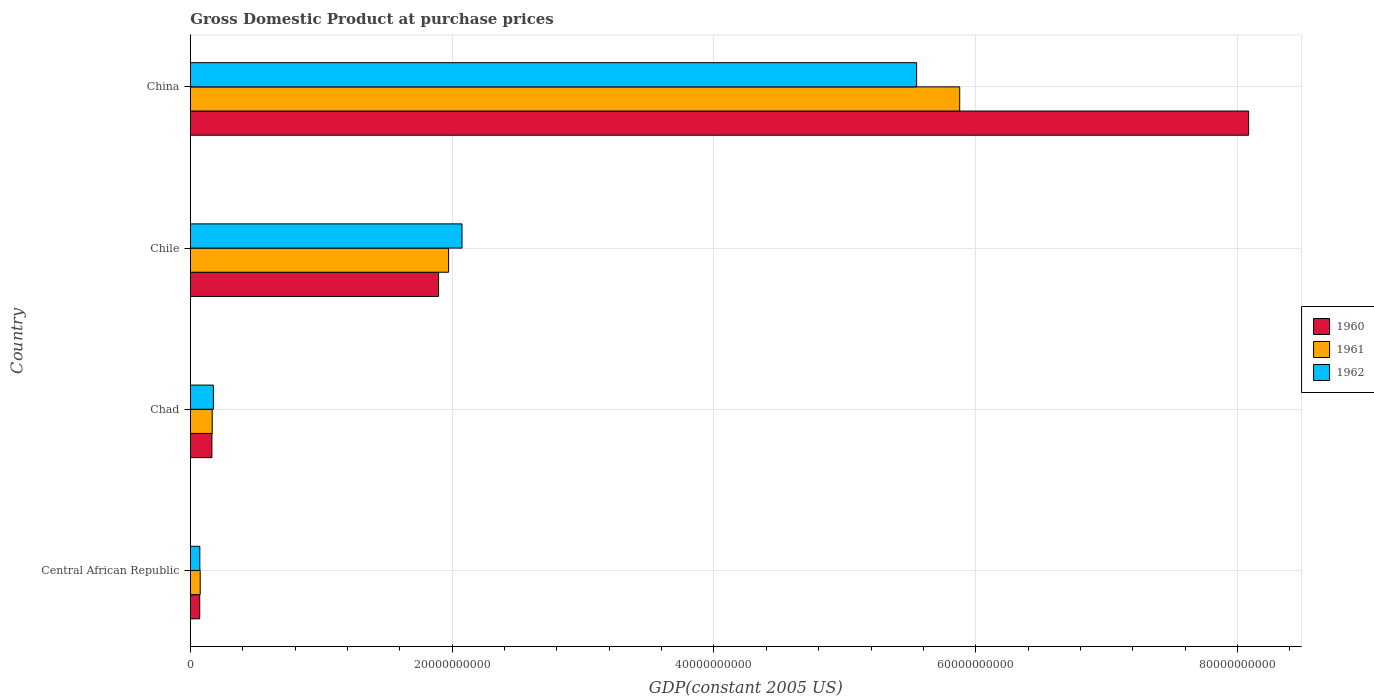How many different coloured bars are there?
Your answer should be compact. 3. How many bars are there on the 3rd tick from the top?
Your answer should be very brief. 3. How many bars are there on the 4th tick from the bottom?
Offer a terse response. 3. What is the label of the 3rd group of bars from the top?
Make the answer very short. Chad. In how many cases, is the number of bars for a given country not equal to the number of legend labels?
Keep it short and to the point. 0. What is the GDP at purchase prices in 1960 in Central African Republic?
Provide a short and direct response. 7.21e+08. Across all countries, what is the maximum GDP at purchase prices in 1961?
Your answer should be compact. 5.88e+1. Across all countries, what is the minimum GDP at purchase prices in 1960?
Provide a short and direct response. 7.21e+08. In which country was the GDP at purchase prices in 1962 minimum?
Your answer should be compact. Central African Republic. What is the total GDP at purchase prices in 1960 in the graph?
Your response must be concise. 1.02e+11. What is the difference between the GDP at purchase prices in 1961 in Chile and that in China?
Your answer should be compact. -3.90e+1. What is the difference between the GDP at purchase prices in 1962 in Central African Republic and the GDP at purchase prices in 1961 in Chad?
Give a very brief answer. -9.46e+08. What is the average GDP at purchase prices in 1960 per country?
Give a very brief answer. 2.55e+1. What is the difference between the GDP at purchase prices in 1962 and GDP at purchase prices in 1960 in Chile?
Offer a terse response. 1.79e+09. In how many countries, is the GDP at purchase prices in 1961 greater than 44000000000 US$?
Ensure brevity in your answer.  1. What is the ratio of the GDP at purchase prices in 1962 in Chad to that in Chile?
Provide a succinct answer. 0.09. Is the GDP at purchase prices in 1960 in Chile less than that in China?
Your answer should be very brief. Yes. Is the difference between the GDP at purchase prices in 1962 in Chad and China greater than the difference between the GDP at purchase prices in 1960 in Chad and China?
Ensure brevity in your answer.  Yes. What is the difference between the highest and the second highest GDP at purchase prices in 1961?
Keep it short and to the point. 3.90e+1. What is the difference between the highest and the lowest GDP at purchase prices in 1960?
Offer a very short reply. 8.01e+1. What does the 1st bar from the top in Central African Republic represents?
Provide a short and direct response. 1962. Is it the case that in every country, the sum of the GDP at purchase prices in 1960 and GDP at purchase prices in 1962 is greater than the GDP at purchase prices in 1961?
Offer a very short reply. Yes. How many countries are there in the graph?
Offer a terse response. 4. What is the difference between two consecutive major ticks on the X-axis?
Give a very brief answer. 2.00e+1. Are the values on the major ticks of X-axis written in scientific E-notation?
Offer a terse response. No. How many legend labels are there?
Keep it short and to the point. 3. What is the title of the graph?
Offer a terse response. Gross Domestic Product at purchase prices. Does "1979" appear as one of the legend labels in the graph?
Make the answer very short. No. What is the label or title of the X-axis?
Make the answer very short. GDP(constant 2005 US). What is the GDP(constant 2005 US) of 1960 in Central African Republic?
Your answer should be very brief. 7.21e+08. What is the GDP(constant 2005 US) in 1961 in Central African Republic?
Your answer should be compact. 7.57e+08. What is the GDP(constant 2005 US) of 1962 in Central African Republic?
Keep it short and to the point. 7.29e+08. What is the GDP(constant 2005 US) of 1960 in Chad?
Keep it short and to the point. 1.65e+09. What is the GDP(constant 2005 US) of 1961 in Chad?
Your answer should be very brief. 1.68e+09. What is the GDP(constant 2005 US) of 1962 in Chad?
Offer a very short reply. 1.77e+09. What is the GDP(constant 2005 US) in 1960 in Chile?
Provide a succinct answer. 1.90e+1. What is the GDP(constant 2005 US) of 1961 in Chile?
Offer a terse response. 1.97e+1. What is the GDP(constant 2005 US) in 1962 in Chile?
Your response must be concise. 2.08e+1. What is the GDP(constant 2005 US) of 1960 in China?
Give a very brief answer. 8.08e+1. What is the GDP(constant 2005 US) of 1961 in China?
Your response must be concise. 5.88e+1. What is the GDP(constant 2005 US) of 1962 in China?
Your response must be concise. 5.55e+1. Across all countries, what is the maximum GDP(constant 2005 US) of 1960?
Offer a very short reply. 8.08e+1. Across all countries, what is the maximum GDP(constant 2005 US) in 1961?
Ensure brevity in your answer.  5.88e+1. Across all countries, what is the maximum GDP(constant 2005 US) in 1962?
Provide a short and direct response. 5.55e+1. Across all countries, what is the minimum GDP(constant 2005 US) in 1960?
Provide a succinct answer. 7.21e+08. Across all countries, what is the minimum GDP(constant 2005 US) of 1961?
Your answer should be very brief. 7.57e+08. Across all countries, what is the minimum GDP(constant 2005 US) of 1962?
Provide a short and direct response. 7.29e+08. What is the total GDP(constant 2005 US) of 1960 in the graph?
Your answer should be compact. 1.02e+11. What is the total GDP(constant 2005 US) in 1961 in the graph?
Provide a succinct answer. 8.09e+1. What is the total GDP(constant 2005 US) of 1962 in the graph?
Ensure brevity in your answer.  7.87e+1. What is the difference between the GDP(constant 2005 US) of 1960 in Central African Republic and that in Chad?
Provide a succinct answer. -9.31e+08. What is the difference between the GDP(constant 2005 US) of 1961 in Central African Republic and that in Chad?
Provide a succinct answer. -9.18e+08. What is the difference between the GDP(constant 2005 US) of 1962 in Central African Republic and that in Chad?
Ensure brevity in your answer.  -1.04e+09. What is the difference between the GDP(constant 2005 US) in 1960 in Central African Republic and that in Chile?
Offer a terse response. -1.82e+1. What is the difference between the GDP(constant 2005 US) of 1961 in Central African Republic and that in Chile?
Your response must be concise. -1.90e+1. What is the difference between the GDP(constant 2005 US) of 1962 in Central African Republic and that in Chile?
Offer a very short reply. -2.00e+1. What is the difference between the GDP(constant 2005 US) in 1960 in Central African Republic and that in China?
Offer a very short reply. -8.01e+1. What is the difference between the GDP(constant 2005 US) of 1961 in Central African Republic and that in China?
Your response must be concise. -5.80e+1. What is the difference between the GDP(constant 2005 US) of 1962 in Central African Republic and that in China?
Provide a short and direct response. -5.48e+1. What is the difference between the GDP(constant 2005 US) of 1960 in Chad and that in Chile?
Provide a short and direct response. -1.73e+1. What is the difference between the GDP(constant 2005 US) in 1961 in Chad and that in Chile?
Your response must be concise. -1.81e+1. What is the difference between the GDP(constant 2005 US) in 1962 in Chad and that in Chile?
Give a very brief answer. -1.90e+1. What is the difference between the GDP(constant 2005 US) of 1960 in Chad and that in China?
Keep it short and to the point. -7.92e+1. What is the difference between the GDP(constant 2005 US) in 1961 in Chad and that in China?
Offer a terse response. -5.71e+1. What is the difference between the GDP(constant 2005 US) in 1962 in Chad and that in China?
Ensure brevity in your answer.  -5.37e+1. What is the difference between the GDP(constant 2005 US) in 1960 in Chile and that in China?
Ensure brevity in your answer.  -6.19e+1. What is the difference between the GDP(constant 2005 US) in 1961 in Chile and that in China?
Your answer should be very brief. -3.90e+1. What is the difference between the GDP(constant 2005 US) in 1962 in Chile and that in China?
Offer a very short reply. -3.47e+1. What is the difference between the GDP(constant 2005 US) of 1960 in Central African Republic and the GDP(constant 2005 US) of 1961 in Chad?
Offer a very short reply. -9.54e+08. What is the difference between the GDP(constant 2005 US) in 1960 in Central African Republic and the GDP(constant 2005 US) in 1962 in Chad?
Offer a terse response. -1.04e+09. What is the difference between the GDP(constant 2005 US) of 1961 in Central African Republic and the GDP(constant 2005 US) of 1962 in Chad?
Offer a terse response. -1.01e+09. What is the difference between the GDP(constant 2005 US) of 1960 in Central African Republic and the GDP(constant 2005 US) of 1961 in Chile?
Make the answer very short. -1.90e+1. What is the difference between the GDP(constant 2005 US) in 1960 in Central African Republic and the GDP(constant 2005 US) in 1962 in Chile?
Your answer should be compact. -2.00e+1. What is the difference between the GDP(constant 2005 US) of 1961 in Central African Republic and the GDP(constant 2005 US) of 1962 in Chile?
Make the answer very short. -2.00e+1. What is the difference between the GDP(constant 2005 US) of 1960 in Central African Republic and the GDP(constant 2005 US) of 1961 in China?
Make the answer very short. -5.81e+1. What is the difference between the GDP(constant 2005 US) in 1960 in Central African Republic and the GDP(constant 2005 US) in 1962 in China?
Keep it short and to the point. -5.48e+1. What is the difference between the GDP(constant 2005 US) in 1961 in Central African Republic and the GDP(constant 2005 US) in 1962 in China?
Give a very brief answer. -5.47e+1. What is the difference between the GDP(constant 2005 US) in 1960 in Chad and the GDP(constant 2005 US) in 1961 in Chile?
Offer a very short reply. -1.81e+1. What is the difference between the GDP(constant 2005 US) in 1960 in Chad and the GDP(constant 2005 US) in 1962 in Chile?
Provide a short and direct response. -1.91e+1. What is the difference between the GDP(constant 2005 US) of 1961 in Chad and the GDP(constant 2005 US) of 1962 in Chile?
Keep it short and to the point. -1.91e+1. What is the difference between the GDP(constant 2005 US) of 1960 in Chad and the GDP(constant 2005 US) of 1961 in China?
Your answer should be very brief. -5.71e+1. What is the difference between the GDP(constant 2005 US) of 1960 in Chad and the GDP(constant 2005 US) of 1962 in China?
Your answer should be very brief. -5.38e+1. What is the difference between the GDP(constant 2005 US) in 1961 in Chad and the GDP(constant 2005 US) in 1962 in China?
Provide a short and direct response. -5.38e+1. What is the difference between the GDP(constant 2005 US) in 1960 in Chile and the GDP(constant 2005 US) in 1961 in China?
Keep it short and to the point. -3.98e+1. What is the difference between the GDP(constant 2005 US) of 1960 in Chile and the GDP(constant 2005 US) of 1962 in China?
Provide a short and direct response. -3.65e+1. What is the difference between the GDP(constant 2005 US) in 1961 in Chile and the GDP(constant 2005 US) in 1962 in China?
Your response must be concise. -3.58e+1. What is the average GDP(constant 2005 US) in 1960 per country?
Your answer should be very brief. 2.55e+1. What is the average GDP(constant 2005 US) in 1961 per country?
Your answer should be very brief. 2.02e+1. What is the average GDP(constant 2005 US) of 1962 per country?
Make the answer very short. 1.97e+1. What is the difference between the GDP(constant 2005 US) of 1960 and GDP(constant 2005 US) of 1961 in Central African Republic?
Keep it short and to the point. -3.57e+07. What is the difference between the GDP(constant 2005 US) of 1960 and GDP(constant 2005 US) of 1962 in Central African Republic?
Offer a terse response. -7.62e+06. What is the difference between the GDP(constant 2005 US) in 1961 and GDP(constant 2005 US) in 1962 in Central African Republic?
Keep it short and to the point. 2.81e+07. What is the difference between the GDP(constant 2005 US) of 1960 and GDP(constant 2005 US) of 1961 in Chad?
Your answer should be very brief. -2.31e+07. What is the difference between the GDP(constant 2005 US) of 1960 and GDP(constant 2005 US) of 1962 in Chad?
Make the answer very short. -1.13e+08. What is the difference between the GDP(constant 2005 US) of 1961 and GDP(constant 2005 US) of 1962 in Chad?
Ensure brevity in your answer.  -8.98e+07. What is the difference between the GDP(constant 2005 US) in 1960 and GDP(constant 2005 US) in 1961 in Chile?
Your response must be concise. -7.68e+08. What is the difference between the GDP(constant 2005 US) of 1960 and GDP(constant 2005 US) of 1962 in Chile?
Keep it short and to the point. -1.79e+09. What is the difference between the GDP(constant 2005 US) of 1961 and GDP(constant 2005 US) of 1962 in Chile?
Offer a very short reply. -1.02e+09. What is the difference between the GDP(constant 2005 US) in 1960 and GDP(constant 2005 US) in 1961 in China?
Your response must be concise. 2.21e+1. What is the difference between the GDP(constant 2005 US) of 1960 and GDP(constant 2005 US) of 1962 in China?
Your answer should be very brief. 2.54e+1. What is the difference between the GDP(constant 2005 US) in 1961 and GDP(constant 2005 US) in 1962 in China?
Offer a terse response. 3.29e+09. What is the ratio of the GDP(constant 2005 US) in 1960 in Central African Republic to that in Chad?
Provide a succinct answer. 0.44. What is the ratio of the GDP(constant 2005 US) of 1961 in Central African Republic to that in Chad?
Ensure brevity in your answer.  0.45. What is the ratio of the GDP(constant 2005 US) of 1962 in Central African Republic to that in Chad?
Offer a very short reply. 0.41. What is the ratio of the GDP(constant 2005 US) in 1960 in Central African Republic to that in Chile?
Ensure brevity in your answer.  0.04. What is the ratio of the GDP(constant 2005 US) of 1961 in Central African Republic to that in Chile?
Your response must be concise. 0.04. What is the ratio of the GDP(constant 2005 US) of 1962 in Central African Republic to that in Chile?
Provide a succinct answer. 0.04. What is the ratio of the GDP(constant 2005 US) in 1960 in Central African Republic to that in China?
Ensure brevity in your answer.  0.01. What is the ratio of the GDP(constant 2005 US) of 1961 in Central African Republic to that in China?
Give a very brief answer. 0.01. What is the ratio of the GDP(constant 2005 US) in 1962 in Central African Republic to that in China?
Keep it short and to the point. 0.01. What is the ratio of the GDP(constant 2005 US) in 1960 in Chad to that in Chile?
Give a very brief answer. 0.09. What is the ratio of the GDP(constant 2005 US) in 1961 in Chad to that in Chile?
Offer a terse response. 0.08. What is the ratio of the GDP(constant 2005 US) in 1962 in Chad to that in Chile?
Offer a very short reply. 0.09. What is the ratio of the GDP(constant 2005 US) of 1960 in Chad to that in China?
Provide a short and direct response. 0.02. What is the ratio of the GDP(constant 2005 US) of 1961 in Chad to that in China?
Ensure brevity in your answer.  0.03. What is the ratio of the GDP(constant 2005 US) of 1962 in Chad to that in China?
Ensure brevity in your answer.  0.03. What is the ratio of the GDP(constant 2005 US) in 1960 in Chile to that in China?
Ensure brevity in your answer.  0.23. What is the ratio of the GDP(constant 2005 US) in 1961 in Chile to that in China?
Provide a succinct answer. 0.34. What is the ratio of the GDP(constant 2005 US) of 1962 in Chile to that in China?
Offer a terse response. 0.37. What is the difference between the highest and the second highest GDP(constant 2005 US) in 1960?
Make the answer very short. 6.19e+1. What is the difference between the highest and the second highest GDP(constant 2005 US) of 1961?
Provide a succinct answer. 3.90e+1. What is the difference between the highest and the second highest GDP(constant 2005 US) in 1962?
Your answer should be very brief. 3.47e+1. What is the difference between the highest and the lowest GDP(constant 2005 US) of 1960?
Provide a short and direct response. 8.01e+1. What is the difference between the highest and the lowest GDP(constant 2005 US) of 1961?
Your response must be concise. 5.80e+1. What is the difference between the highest and the lowest GDP(constant 2005 US) of 1962?
Your answer should be compact. 5.48e+1. 